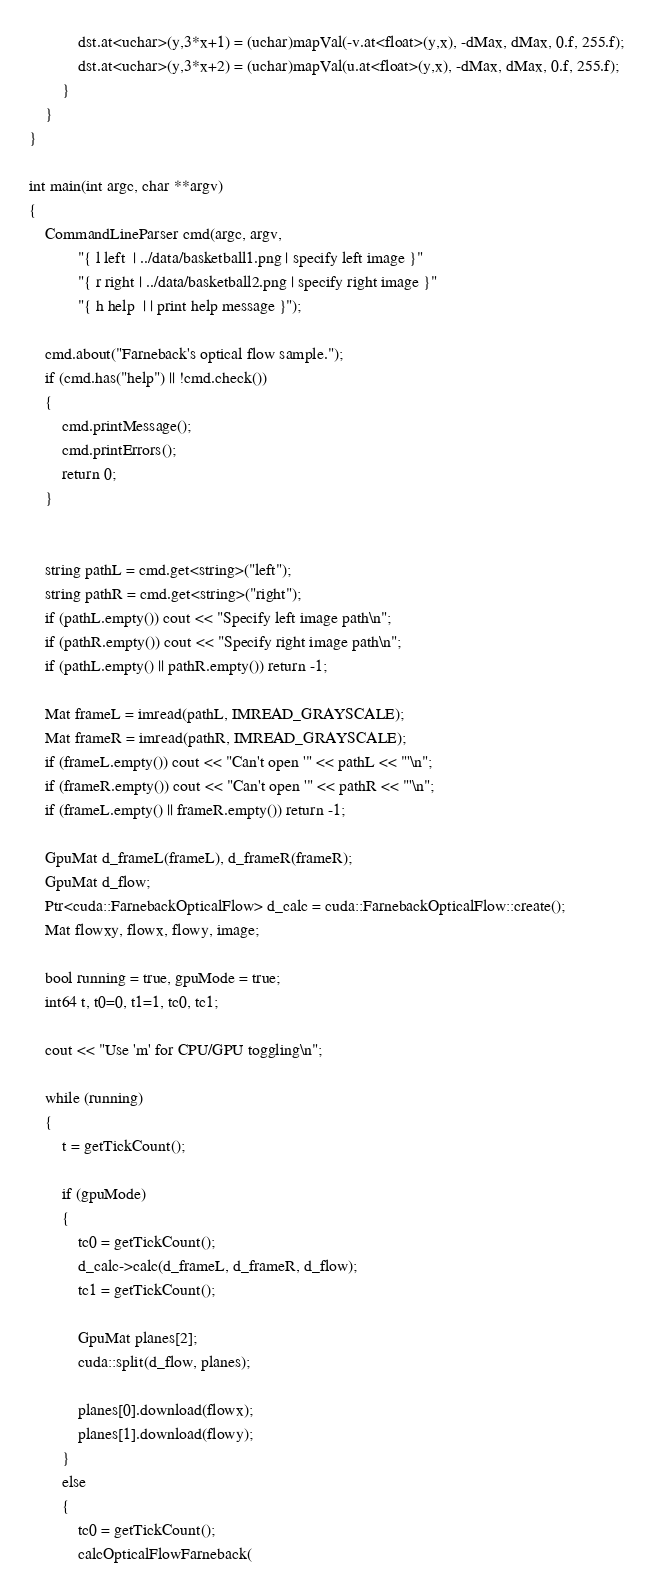Convert code to text. <code><loc_0><loc_0><loc_500><loc_500><_C++_>            dst.at<uchar>(y,3*x+1) = (uchar)mapVal(-v.at<float>(y,x), -dMax, dMax, 0.f, 255.f);
            dst.at<uchar>(y,3*x+2) = (uchar)mapVal(u.at<float>(y,x), -dMax, dMax, 0.f, 255.f);
        }
    }
}

int main(int argc, char **argv)
{
    CommandLineParser cmd(argc, argv,
            "{ l left  | ../data/basketball1.png | specify left image }"
            "{ r right | ../data/basketball2.png | specify right image }"
            "{ h help  | | print help message }");

    cmd.about("Farneback's optical flow sample.");
    if (cmd.has("help") || !cmd.check())
    {
        cmd.printMessage();
        cmd.printErrors();
        return 0;
    }


    string pathL = cmd.get<string>("left");
    string pathR = cmd.get<string>("right");
    if (pathL.empty()) cout << "Specify left image path\n";
    if (pathR.empty()) cout << "Specify right image path\n";
    if (pathL.empty() || pathR.empty()) return -1;

    Mat frameL = imread(pathL, IMREAD_GRAYSCALE);
    Mat frameR = imread(pathR, IMREAD_GRAYSCALE);
    if (frameL.empty()) cout << "Can't open '" << pathL << "'\n";
    if (frameR.empty()) cout << "Can't open '" << pathR << "'\n";
    if (frameL.empty() || frameR.empty()) return -1;

    GpuMat d_frameL(frameL), d_frameR(frameR);
    GpuMat d_flow;
    Ptr<cuda::FarnebackOpticalFlow> d_calc = cuda::FarnebackOpticalFlow::create();
    Mat flowxy, flowx, flowy, image;

    bool running = true, gpuMode = true;
    int64 t, t0=0, t1=1, tc0, tc1;

    cout << "Use 'm' for CPU/GPU toggling\n";

    while (running)
    {
        t = getTickCount();

        if (gpuMode)
        {
            tc0 = getTickCount();
            d_calc->calc(d_frameL, d_frameR, d_flow);
            tc1 = getTickCount();

            GpuMat planes[2];
            cuda::split(d_flow, planes);

            planes[0].download(flowx);
            planes[1].download(flowy);
        }
        else
        {
            tc0 = getTickCount();
            calcOpticalFlowFarneback(</code> 